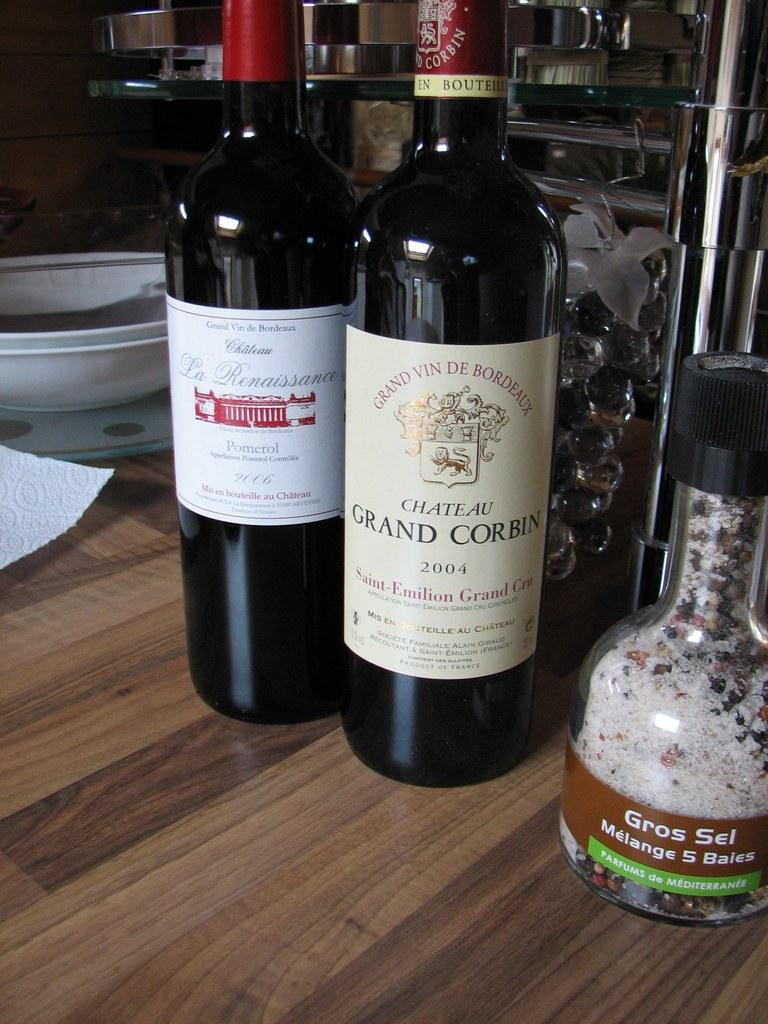<image>
Create a compact narrative representing the image presented. Wine bottle with a label that says the year 2004 on it. 